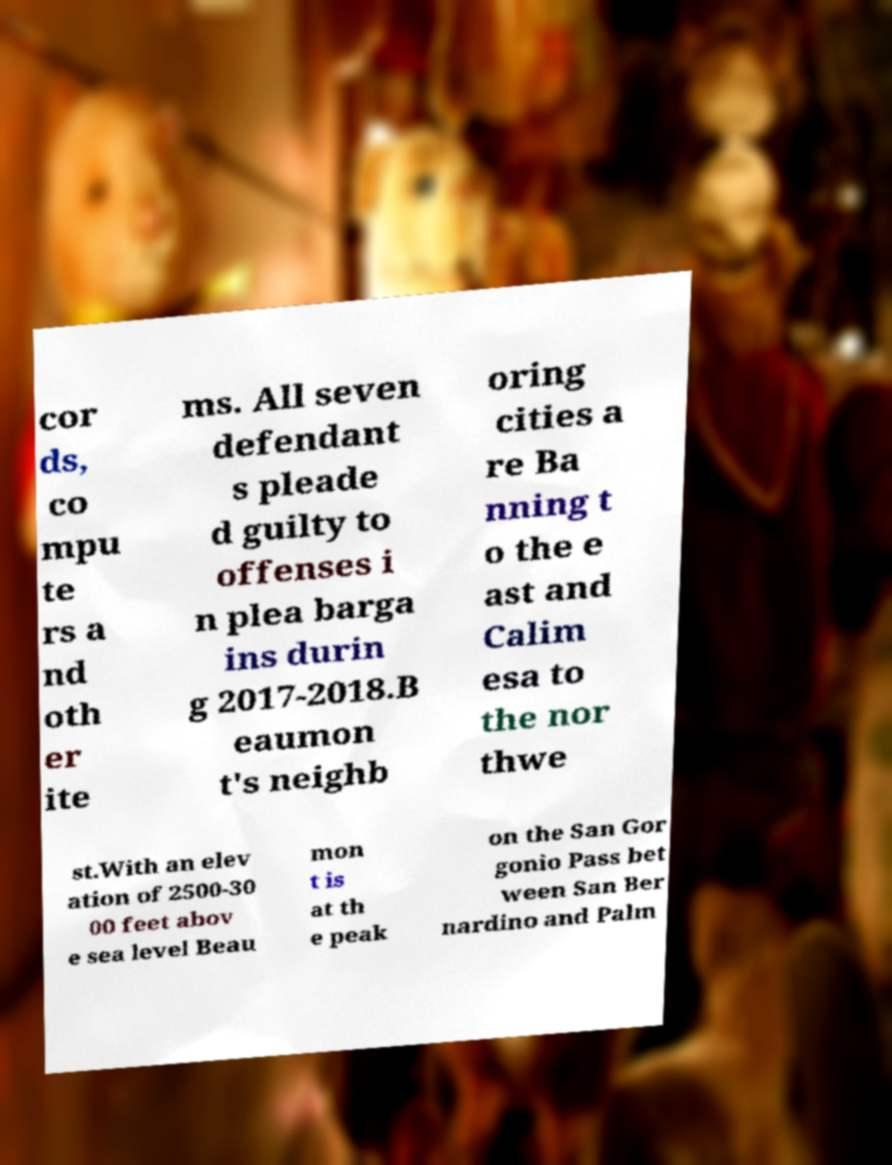Please identify and transcribe the text found in this image. cor ds, co mpu te rs a nd oth er ite ms. All seven defendant s pleade d guilty to offenses i n plea barga ins durin g 2017-2018.B eaumon t's neighb oring cities a re Ba nning t o the e ast and Calim esa to the nor thwe st.With an elev ation of 2500-30 00 feet abov e sea level Beau mon t is at th e peak on the San Gor gonio Pass bet ween San Ber nardino and Palm 